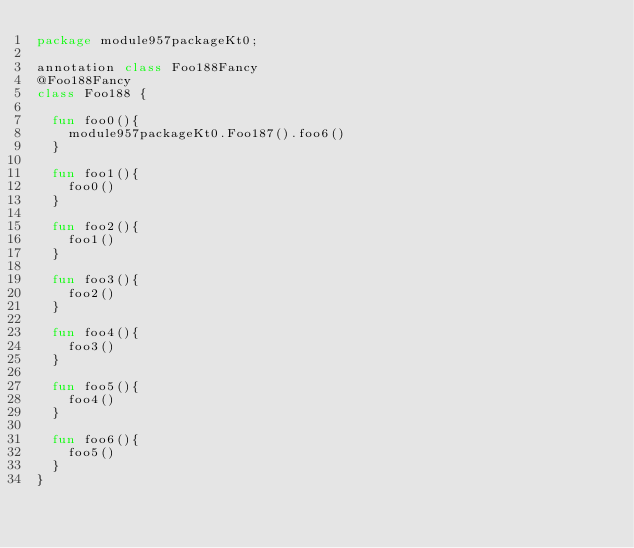<code> <loc_0><loc_0><loc_500><loc_500><_Kotlin_>package module957packageKt0;

annotation class Foo188Fancy
@Foo188Fancy
class Foo188 {

  fun foo0(){
    module957packageKt0.Foo187().foo6()
  }

  fun foo1(){
    foo0()
  }

  fun foo2(){
    foo1()
  }

  fun foo3(){
    foo2()
  }

  fun foo4(){
    foo3()
  }

  fun foo5(){
    foo4()
  }

  fun foo6(){
    foo5()
  }
}</code> 